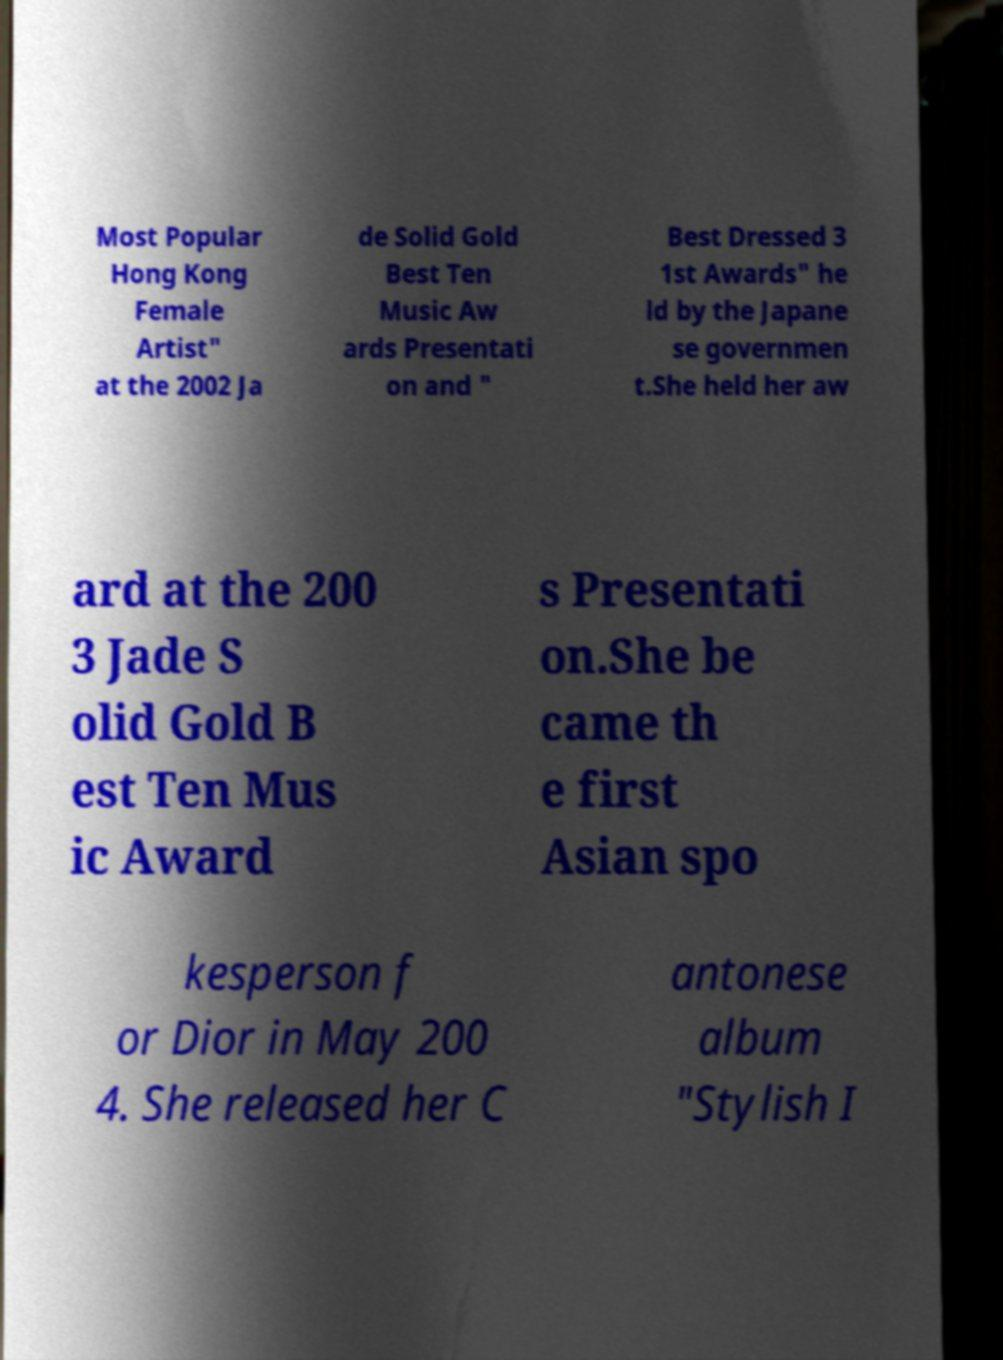Could you assist in decoding the text presented in this image and type it out clearly? Most Popular Hong Kong Female Artist" at the 2002 Ja de Solid Gold Best Ten Music Aw ards Presentati on and " Best Dressed 3 1st Awards" he ld by the Japane se governmen t.She held her aw ard at the 200 3 Jade S olid Gold B est Ten Mus ic Award s Presentati on.She be came th e first Asian spo kesperson f or Dior in May 200 4. She released her C antonese album "Stylish I 